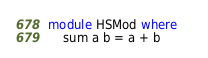<code> <loc_0><loc_0><loc_500><loc_500><_Haskell_>module HSMod where    
    sum a b = a + b</code> 